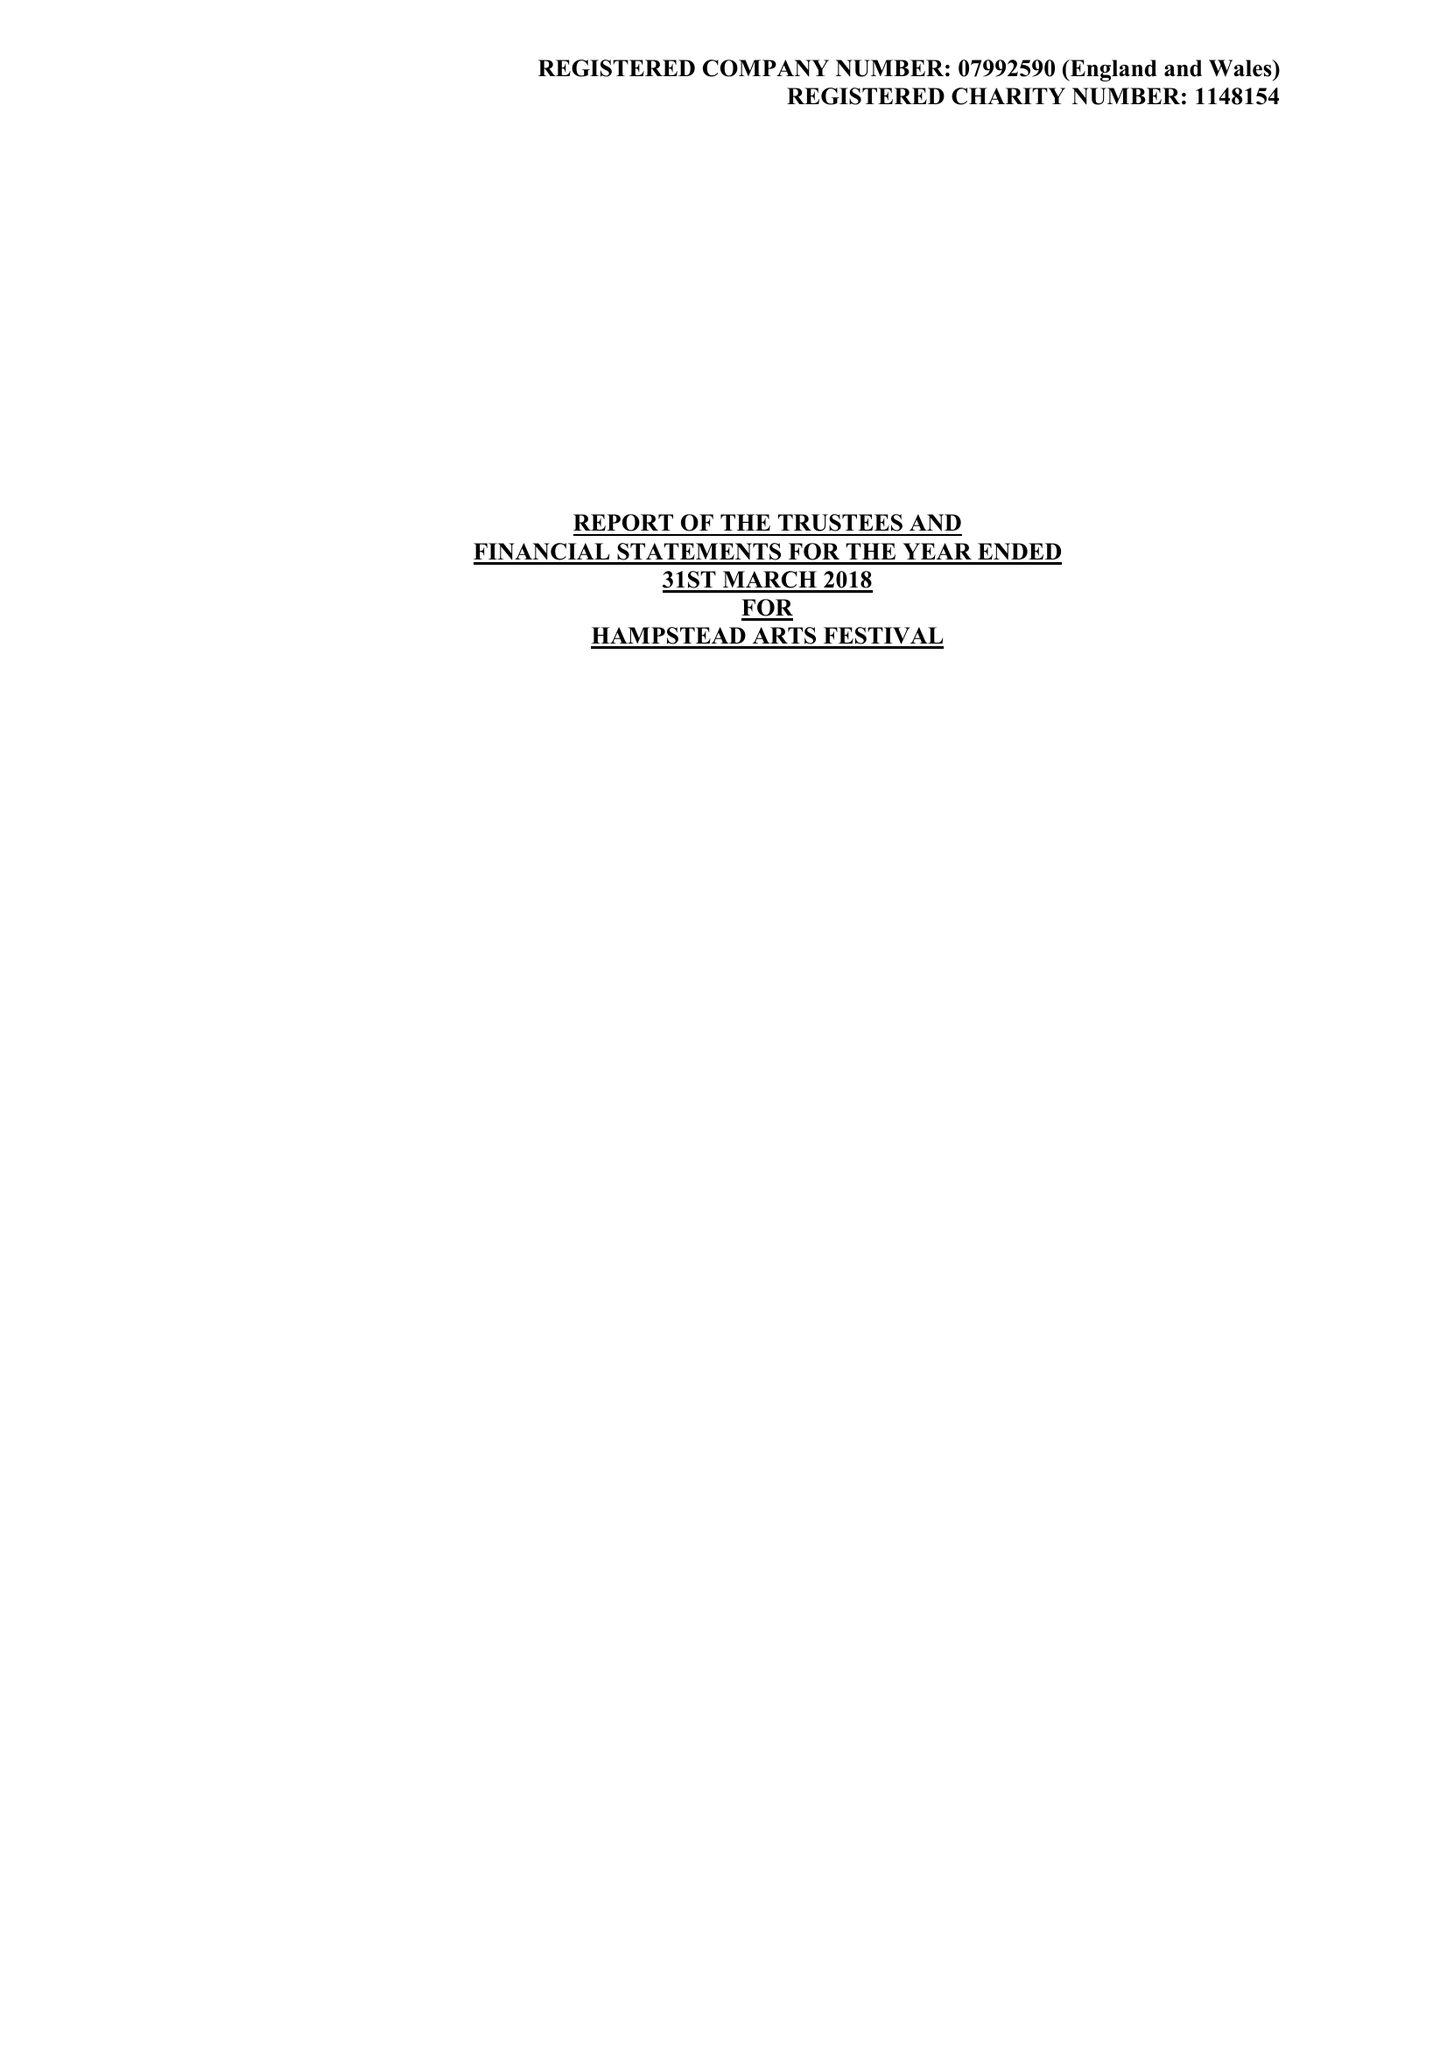What is the value for the charity_number?
Answer the question using a single word or phrase. 1148154 